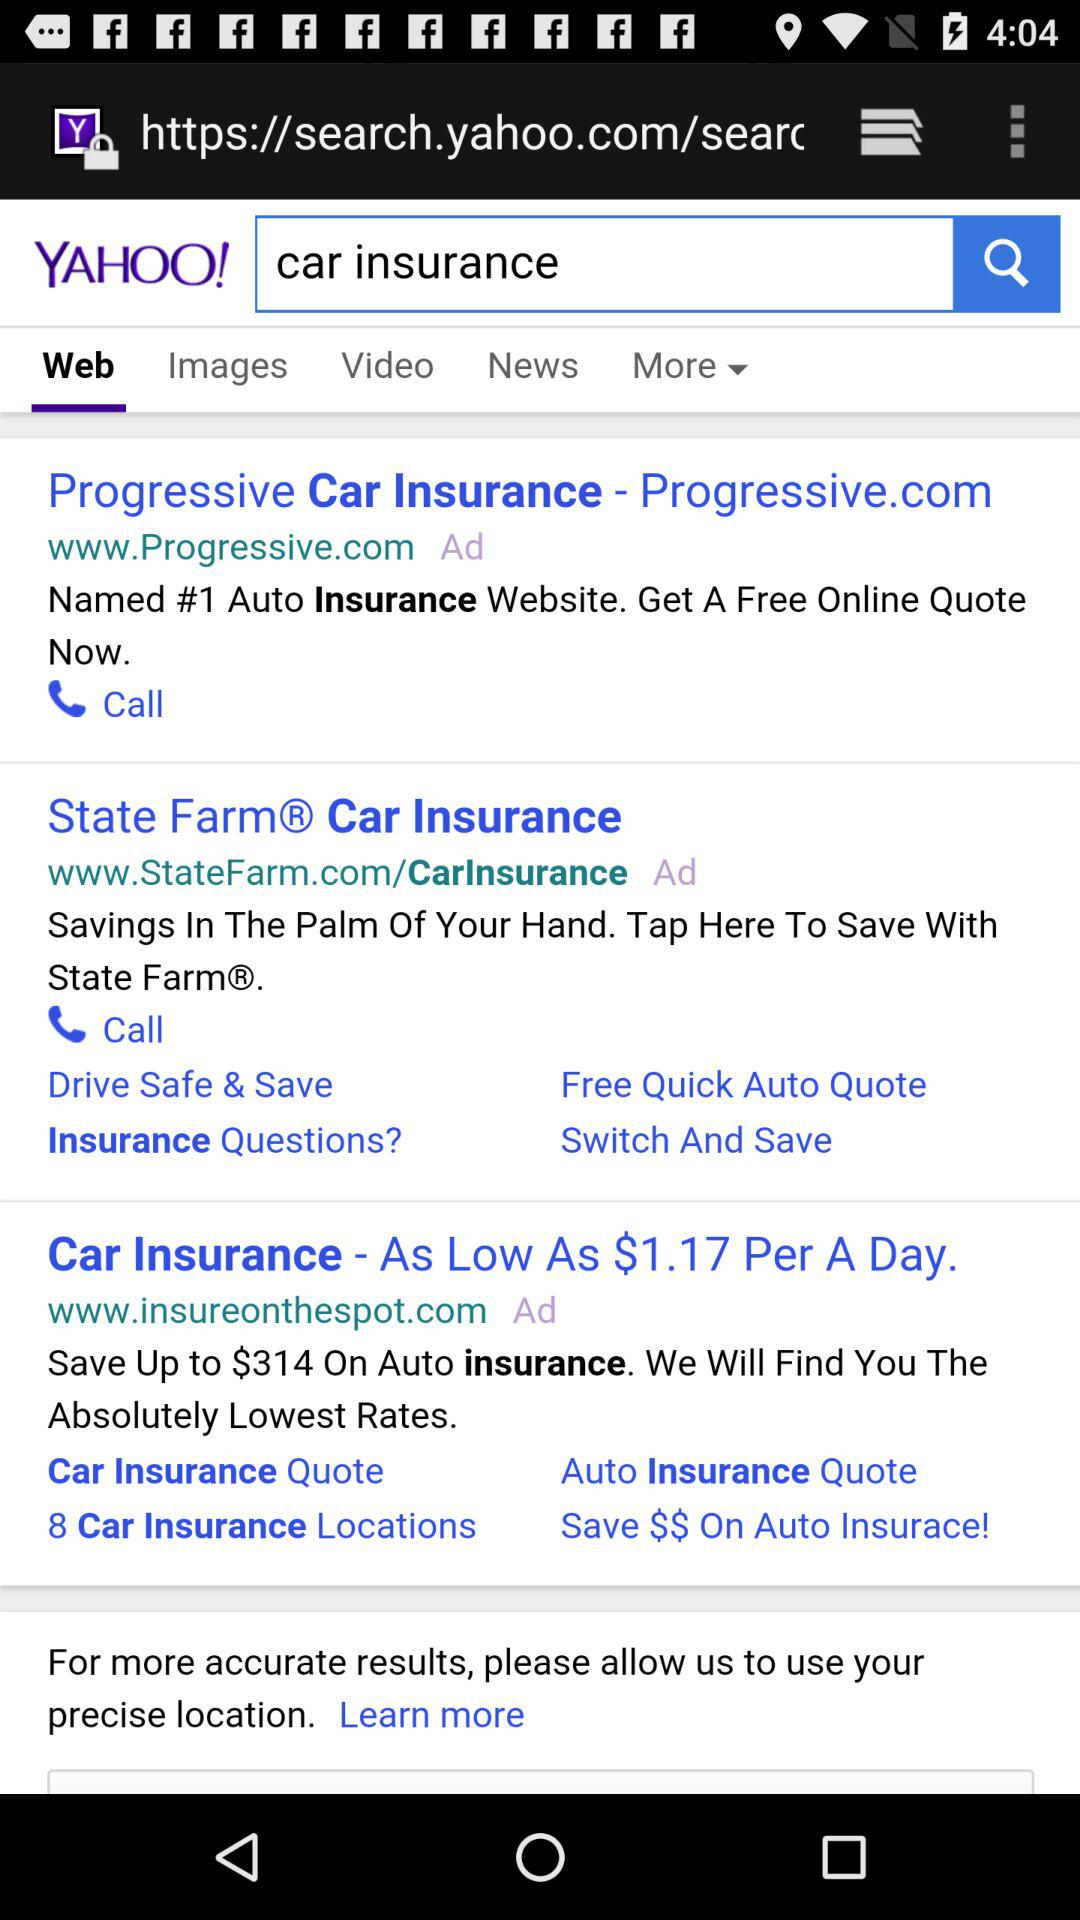What is the text entered into the search bar? The text entered into the search bar is "car insurance". 